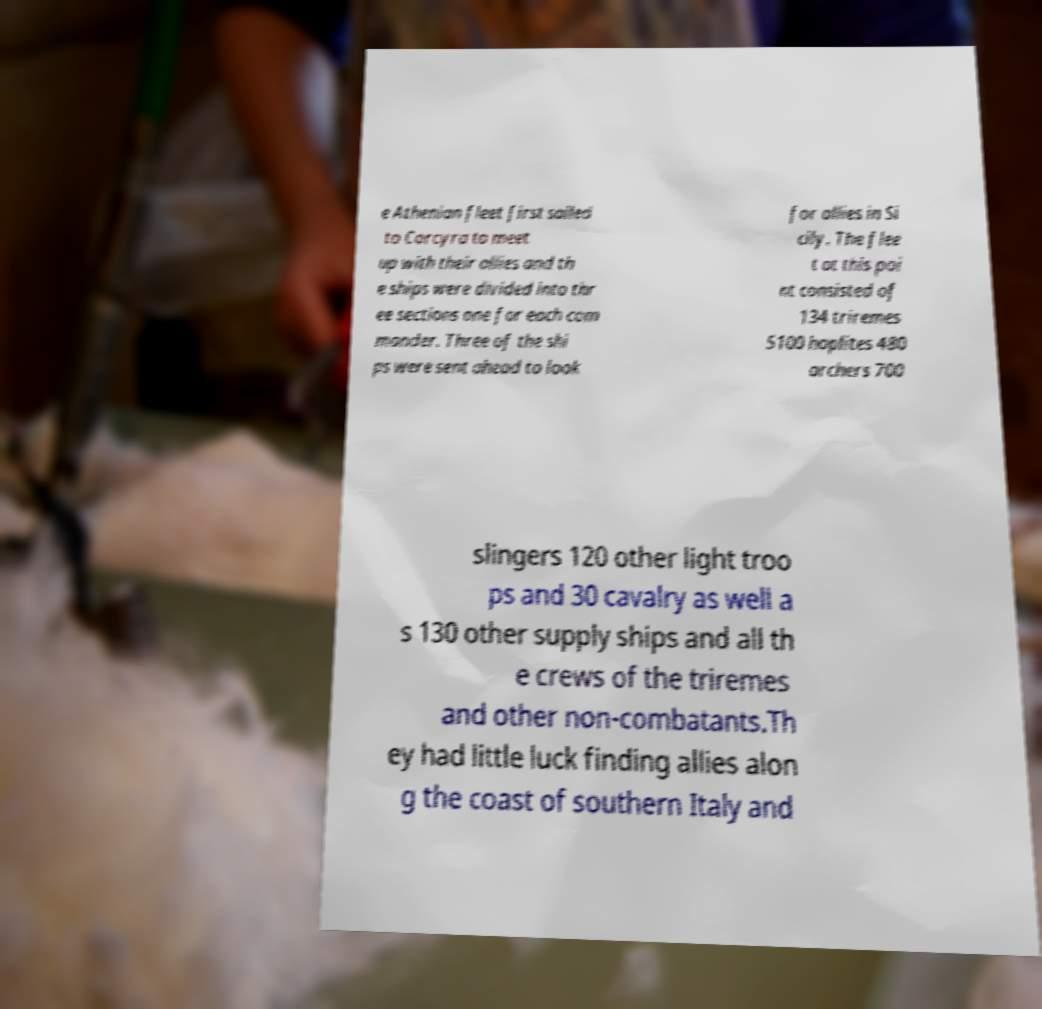What messages or text are displayed in this image? I need them in a readable, typed format. e Athenian fleet first sailed to Corcyra to meet up with their allies and th e ships were divided into thr ee sections one for each com mander. Three of the shi ps were sent ahead to look for allies in Si cily. The flee t at this poi nt consisted of 134 triremes 5100 hoplites 480 archers 700 slingers 120 other light troo ps and 30 cavalry as well a s 130 other supply ships and all th e crews of the triremes and other non-combatants.Th ey had little luck finding allies alon g the coast of southern Italy and 